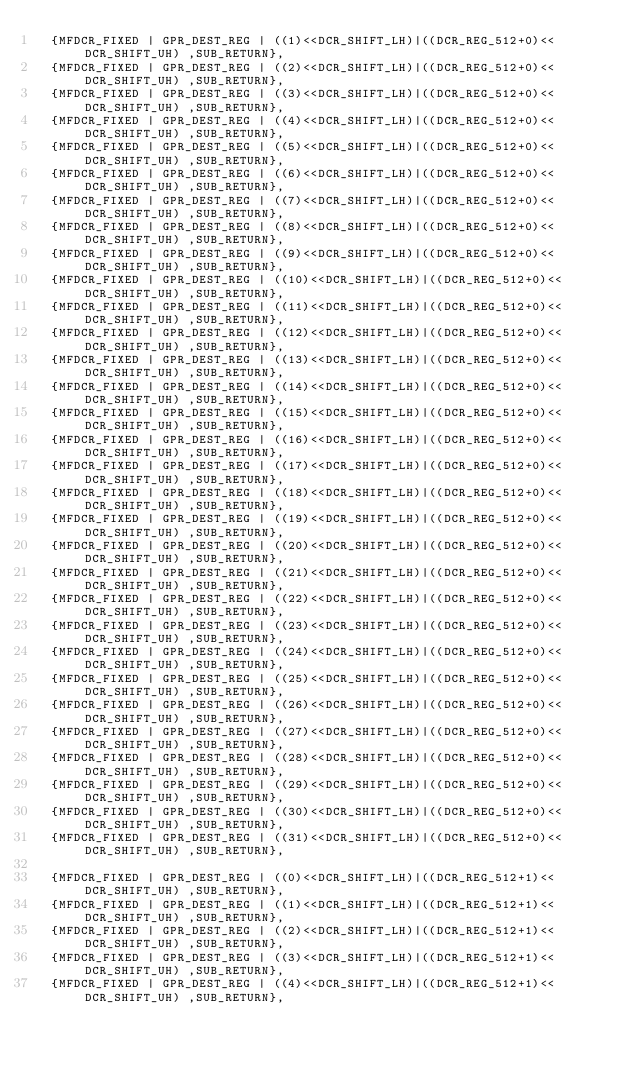<code> <loc_0><loc_0><loc_500><loc_500><_C_>  {MFDCR_FIXED | GPR_DEST_REG | ((1)<<DCR_SHIFT_LH)|((DCR_REG_512+0)<<DCR_SHIFT_UH) ,SUB_RETURN},
  {MFDCR_FIXED | GPR_DEST_REG | ((2)<<DCR_SHIFT_LH)|((DCR_REG_512+0)<<DCR_SHIFT_UH) ,SUB_RETURN},
  {MFDCR_FIXED | GPR_DEST_REG | ((3)<<DCR_SHIFT_LH)|((DCR_REG_512+0)<<DCR_SHIFT_UH) ,SUB_RETURN},
  {MFDCR_FIXED | GPR_DEST_REG | ((4)<<DCR_SHIFT_LH)|((DCR_REG_512+0)<<DCR_SHIFT_UH) ,SUB_RETURN},
  {MFDCR_FIXED | GPR_DEST_REG | ((5)<<DCR_SHIFT_LH)|((DCR_REG_512+0)<<DCR_SHIFT_UH) ,SUB_RETURN},
  {MFDCR_FIXED | GPR_DEST_REG | ((6)<<DCR_SHIFT_LH)|((DCR_REG_512+0)<<DCR_SHIFT_UH) ,SUB_RETURN},
  {MFDCR_FIXED | GPR_DEST_REG | ((7)<<DCR_SHIFT_LH)|((DCR_REG_512+0)<<DCR_SHIFT_UH) ,SUB_RETURN},
  {MFDCR_FIXED | GPR_DEST_REG | ((8)<<DCR_SHIFT_LH)|((DCR_REG_512+0)<<DCR_SHIFT_UH) ,SUB_RETURN},
  {MFDCR_FIXED | GPR_DEST_REG | ((9)<<DCR_SHIFT_LH)|((DCR_REG_512+0)<<DCR_SHIFT_UH) ,SUB_RETURN},
  {MFDCR_FIXED | GPR_DEST_REG | ((10)<<DCR_SHIFT_LH)|((DCR_REG_512+0)<<DCR_SHIFT_UH) ,SUB_RETURN},
  {MFDCR_FIXED | GPR_DEST_REG | ((11)<<DCR_SHIFT_LH)|((DCR_REG_512+0)<<DCR_SHIFT_UH) ,SUB_RETURN},
  {MFDCR_FIXED | GPR_DEST_REG | ((12)<<DCR_SHIFT_LH)|((DCR_REG_512+0)<<DCR_SHIFT_UH) ,SUB_RETURN},
  {MFDCR_FIXED | GPR_DEST_REG | ((13)<<DCR_SHIFT_LH)|((DCR_REG_512+0)<<DCR_SHIFT_UH) ,SUB_RETURN},
  {MFDCR_FIXED | GPR_DEST_REG | ((14)<<DCR_SHIFT_LH)|((DCR_REG_512+0)<<DCR_SHIFT_UH) ,SUB_RETURN},
  {MFDCR_FIXED | GPR_DEST_REG | ((15)<<DCR_SHIFT_LH)|((DCR_REG_512+0)<<DCR_SHIFT_UH) ,SUB_RETURN},
  {MFDCR_FIXED | GPR_DEST_REG | ((16)<<DCR_SHIFT_LH)|((DCR_REG_512+0)<<DCR_SHIFT_UH) ,SUB_RETURN},
  {MFDCR_FIXED | GPR_DEST_REG | ((17)<<DCR_SHIFT_LH)|((DCR_REG_512+0)<<DCR_SHIFT_UH) ,SUB_RETURN},
  {MFDCR_FIXED | GPR_DEST_REG | ((18)<<DCR_SHIFT_LH)|((DCR_REG_512+0)<<DCR_SHIFT_UH) ,SUB_RETURN},
  {MFDCR_FIXED | GPR_DEST_REG | ((19)<<DCR_SHIFT_LH)|((DCR_REG_512+0)<<DCR_SHIFT_UH) ,SUB_RETURN},
  {MFDCR_FIXED | GPR_DEST_REG | ((20)<<DCR_SHIFT_LH)|((DCR_REG_512+0)<<DCR_SHIFT_UH) ,SUB_RETURN},
  {MFDCR_FIXED | GPR_DEST_REG | ((21)<<DCR_SHIFT_LH)|((DCR_REG_512+0)<<DCR_SHIFT_UH) ,SUB_RETURN},
  {MFDCR_FIXED | GPR_DEST_REG | ((22)<<DCR_SHIFT_LH)|((DCR_REG_512+0)<<DCR_SHIFT_UH) ,SUB_RETURN},
  {MFDCR_FIXED | GPR_DEST_REG | ((23)<<DCR_SHIFT_LH)|((DCR_REG_512+0)<<DCR_SHIFT_UH) ,SUB_RETURN},
  {MFDCR_FIXED | GPR_DEST_REG | ((24)<<DCR_SHIFT_LH)|((DCR_REG_512+0)<<DCR_SHIFT_UH) ,SUB_RETURN},
  {MFDCR_FIXED | GPR_DEST_REG | ((25)<<DCR_SHIFT_LH)|((DCR_REG_512+0)<<DCR_SHIFT_UH) ,SUB_RETURN},
  {MFDCR_FIXED | GPR_DEST_REG | ((26)<<DCR_SHIFT_LH)|((DCR_REG_512+0)<<DCR_SHIFT_UH) ,SUB_RETURN},
  {MFDCR_FIXED | GPR_DEST_REG | ((27)<<DCR_SHIFT_LH)|((DCR_REG_512+0)<<DCR_SHIFT_UH) ,SUB_RETURN},
  {MFDCR_FIXED | GPR_DEST_REG | ((28)<<DCR_SHIFT_LH)|((DCR_REG_512+0)<<DCR_SHIFT_UH) ,SUB_RETURN},
  {MFDCR_FIXED | GPR_DEST_REG | ((29)<<DCR_SHIFT_LH)|((DCR_REG_512+0)<<DCR_SHIFT_UH) ,SUB_RETURN},
  {MFDCR_FIXED | GPR_DEST_REG | ((30)<<DCR_SHIFT_LH)|((DCR_REG_512+0)<<DCR_SHIFT_UH) ,SUB_RETURN},
  {MFDCR_FIXED | GPR_DEST_REG | ((31)<<DCR_SHIFT_LH)|((DCR_REG_512+0)<<DCR_SHIFT_UH) ,SUB_RETURN},

  {MFDCR_FIXED | GPR_DEST_REG | ((0)<<DCR_SHIFT_LH)|((DCR_REG_512+1)<<DCR_SHIFT_UH) ,SUB_RETURN},
  {MFDCR_FIXED | GPR_DEST_REG | ((1)<<DCR_SHIFT_LH)|((DCR_REG_512+1)<<DCR_SHIFT_UH) ,SUB_RETURN},
  {MFDCR_FIXED | GPR_DEST_REG | ((2)<<DCR_SHIFT_LH)|((DCR_REG_512+1)<<DCR_SHIFT_UH) ,SUB_RETURN},
  {MFDCR_FIXED | GPR_DEST_REG | ((3)<<DCR_SHIFT_LH)|((DCR_REG_512+1)<<DCR_SHIFT_UH) ,SUB_RETURN},
  {MFDCR_FIXED | GPR_DEST_REG | ((4)<<DCR_SHIFT_LH)|((DCR_REG_512+1)<<DCR_SHIFT_UH) ,SUB_RETURN},</code> 